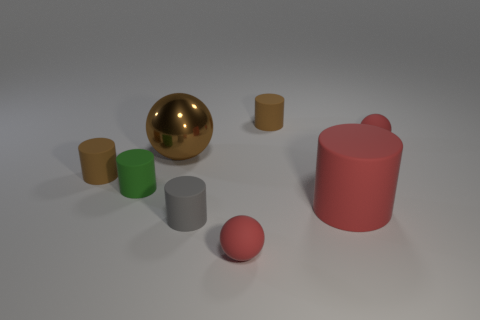What number of shiny things are large purple cylinders or tiny green cylinders?
Your answer should be compact. 0. There is a tiny red sphere that is in front of the red thing behind the brown sphere; are there any objects right of it?
Your answer should be very brief. Yes. There is a red matte cylinder; what number of red rubber spheres are on the left side of it?
Offer a terse response. 1. How many tiny things are either green rubber objects or cylinders?
Provide a succinct answer. 4. What shape is the small green object to the left of the large red rubber cylinder?
Make the answer very short. Cylinder. Are there any other large shiny things of the same color as the metal object?
Give a very brief answer. No. There is a cylinder that is in front of the big red matte cylinder; is it the same size as the rubber ball in front of the tiny green rubber cylinder?
Give a very brief answer. Yes. Are there more small brown cylinders that are in front of the large cylinder than tiny gray rubber cylinders behind the gray rubber cylinder?
Keep it short and to the point. No. Are there any green things that have the same material as the big red object?
Your response must be concise. Yes. Is the color of the big matte object the same as the big sphere?
Your answer should be compact. No. 